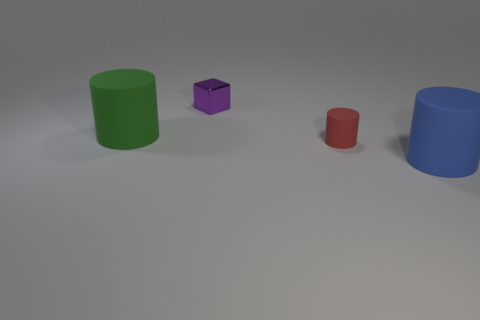Subtract all blue cylinders. Subtract all gray spheres. How many cylinders are left? 2 Add 2 small rubber cylinders. How many objects exist? 6 Subtract all cylinders. How many objects are left? 1 Add 3 large green matte cylinders. How many large green matte cylinders are left? 4 Add 4 tiny metal objects. How many tiny metal objects exist? 5 Subtract 0 brown balls. How many objects are left? 4 Subtract all large green cylinders. Subtract all red rubber things. How many objects are left? 2 